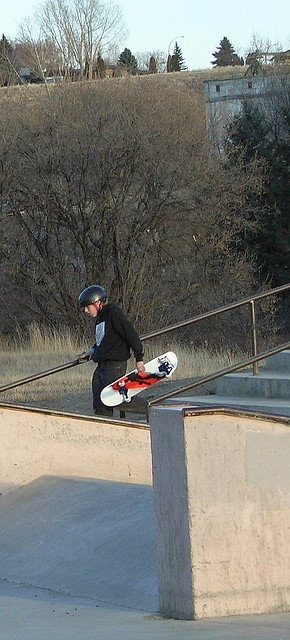Describe the objects in this image and their specific colors. I can see people in white, black, gray, and brown tones and skateboard in white, ivory, black, darkgray, and maroon tones in this image. 